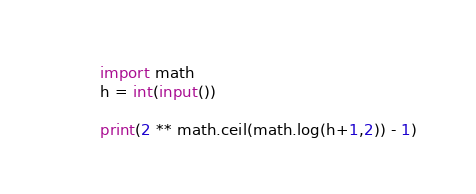<code> <loc_0><loc_0><loc_500><loc_500><_Python_>import math
h = int(input())

print(2 ** math.ceil(math.log(h+1,2)) - 1)
</code> 